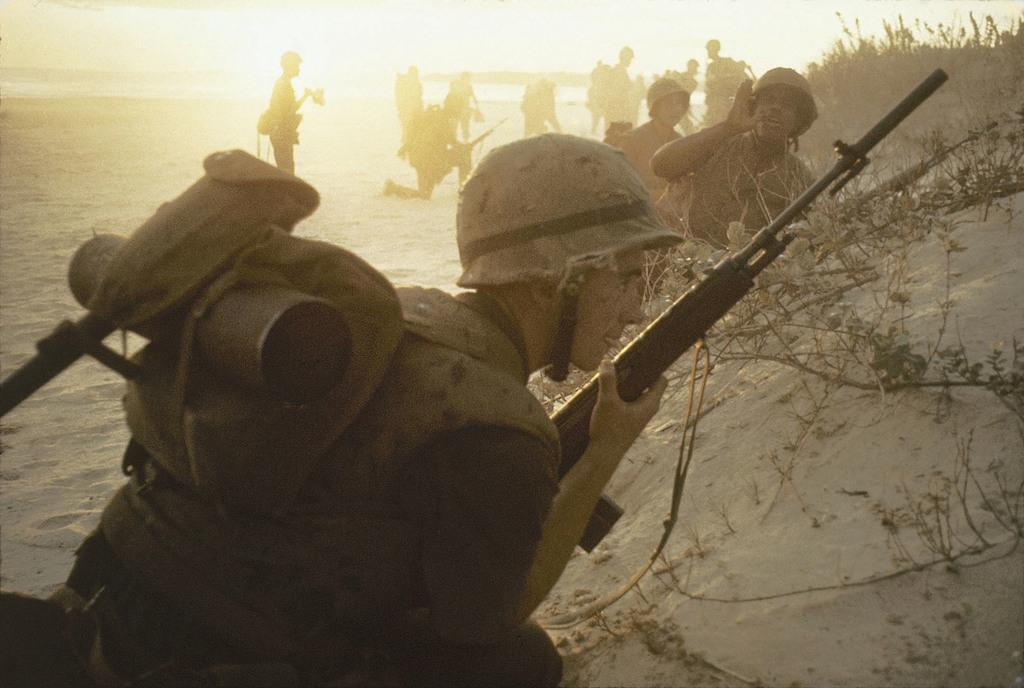What are the people in the image doing? There are people standing and sitting in the squat position in the image. What are the people holding in the image? The people are holding what appear to be branches. What is the ground made of in the image? The ground appears to be sand. How many birds can be seen flying in the image? There are no birds visible in the image. 